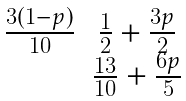Convert formula to latex. <formula><loc_0><loc_0><loc_500><loc_500>\begin{matrix} \frac { 3 ( 1 - p ) } { 1 0 } & \frac { 1 } { 2 } + \frac { 3 p } { 2 } \\ & \frac { 1 3 } { 1 0 } + \frac { 6 p } { 5 } \end{matrix}</formula> 